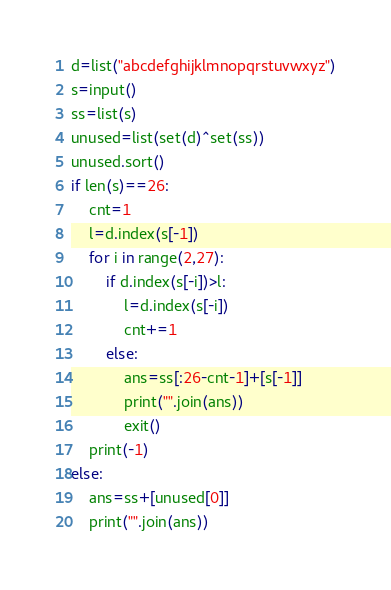<code> <loc_0><loc_0><loc_500><loc_500><_Python_>d=list("abcdefghijklmnopqrstuvwxyz")
s=input()
ss=list(s)
unused=list(set(d)^set(ss))
unused.sort()
if len(s)==26:
    cnt=1
    l=d.index(s[-1])
    for i in range(2,27):
        if d.index(s[-i])>l:
            l=d.index(s[-i])
            cnt+=1
        else:
            ans=ss[:26-cnt-1]+[s[-1]]
            print("".join(ans))
            exit()
    print(-1)
else:
    ans=ss+[unused[0]]
    print("".join(ans))</code> 